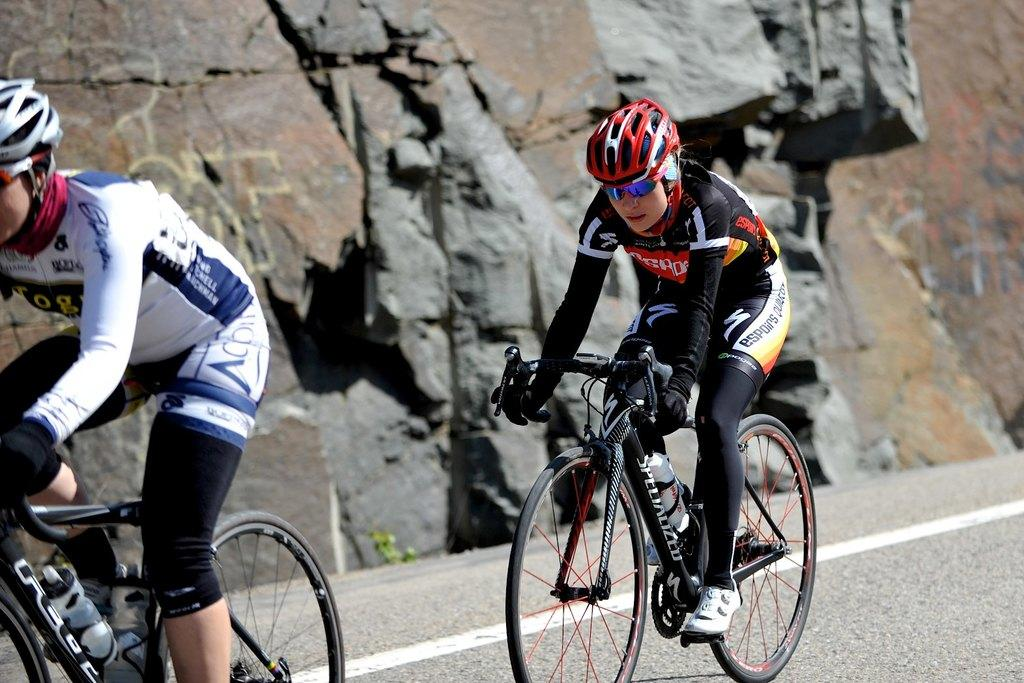How many people are in the image? There are two persons in the image. What are the persons doing in the image? The persons are riding bicycles. Where are the bicycles located? The bicycles are on a road. What can be seen in the background of the image? There is a rock visible in the background of the image. What type of steel is used to construct the bicycles in the image? There is no information about the type of steel used to construct the bicycles in the image. How much force is being applied by the persons riding the bicycles in the image? There is no way to determine the amount of force being applied by the persons riding the bicycles in the image. 